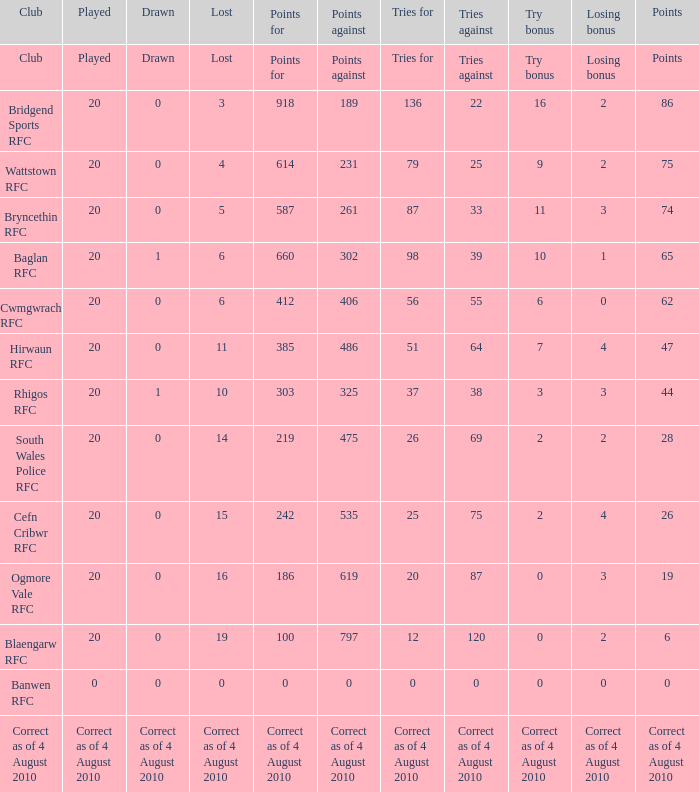What is the tries fow when losing bonus is losing bonus? Tries for. 